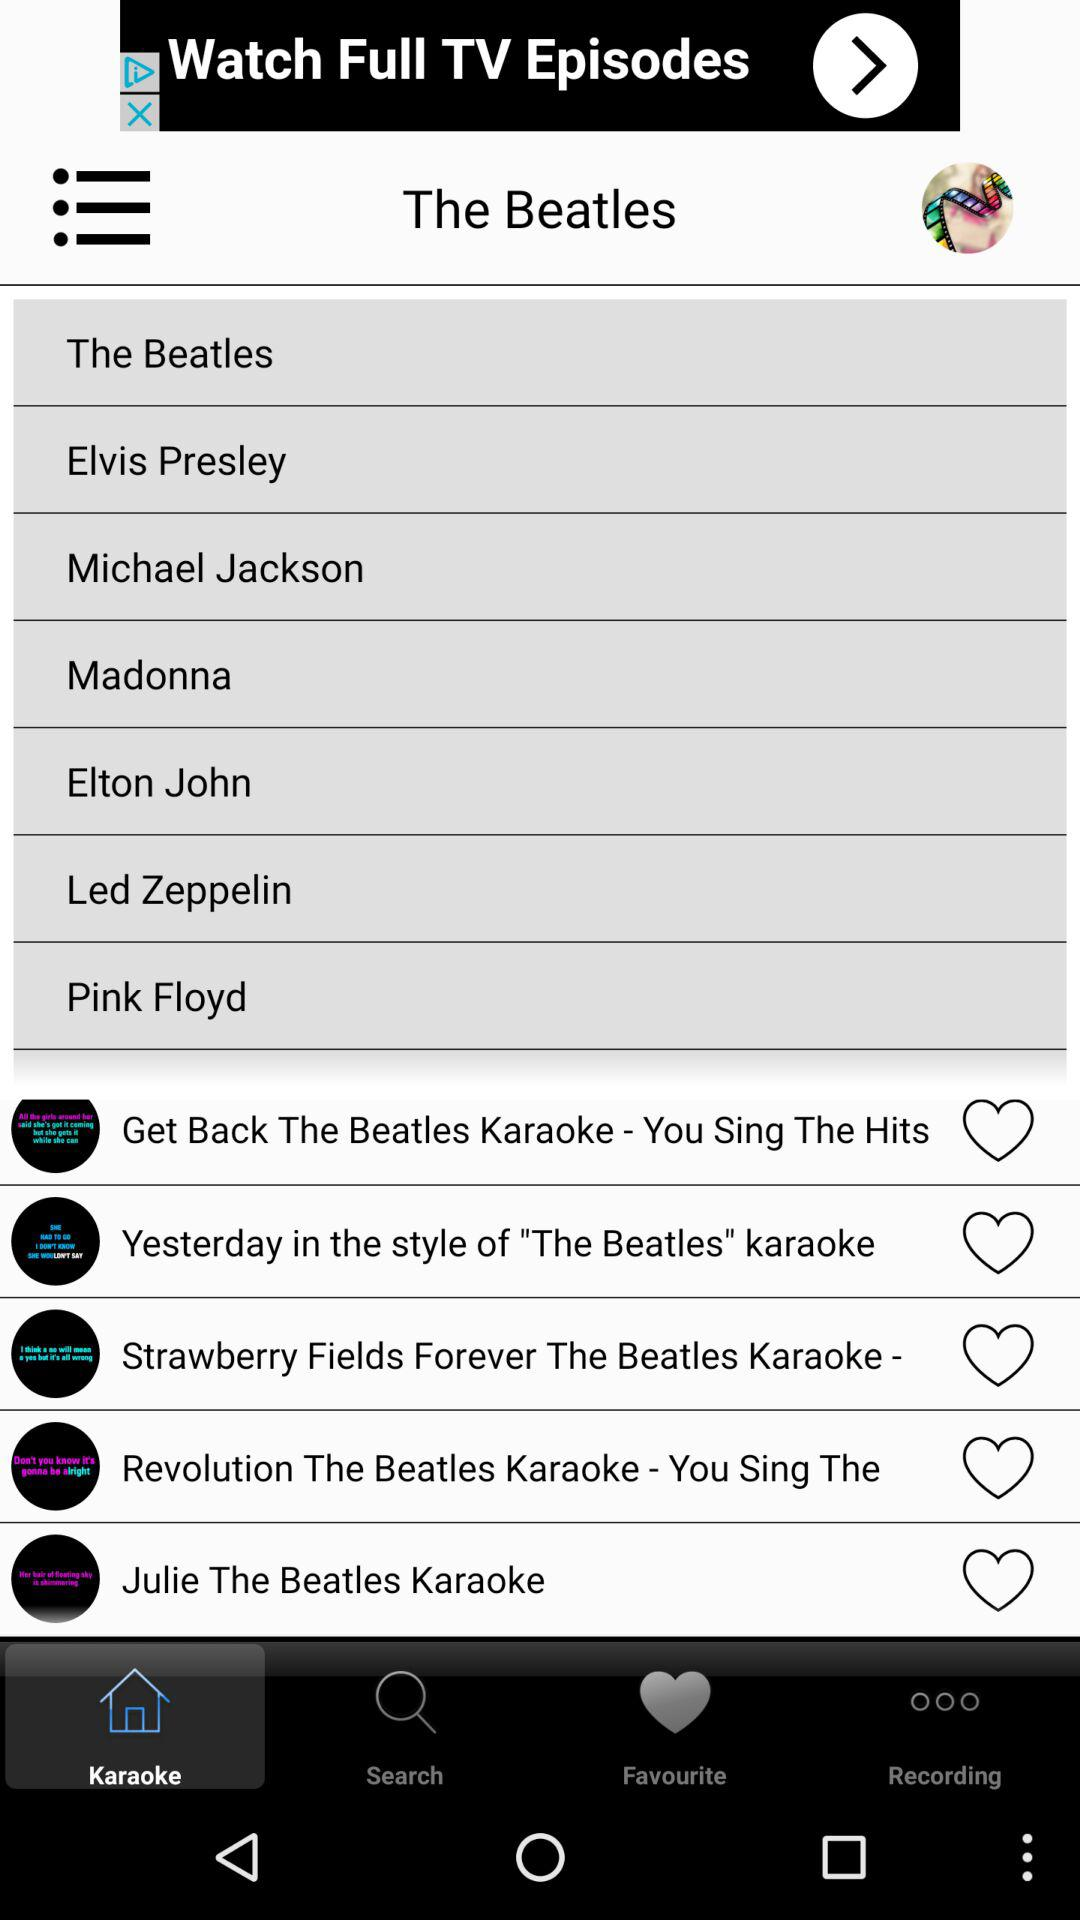What are the karaoke songs of the "Beatles" band? The karaoke songs of the "Beatles" band are "Get Back The Beatles Karaoke - You Sing The Hits", "Yesterday in the style of "The Beatles" karaoke", "Strawberry Fields Forever The Beatles Karaoke -", "Revolution The Beatles Karaoke - You Sing The" and "Julie The Beatles Karaoke". 